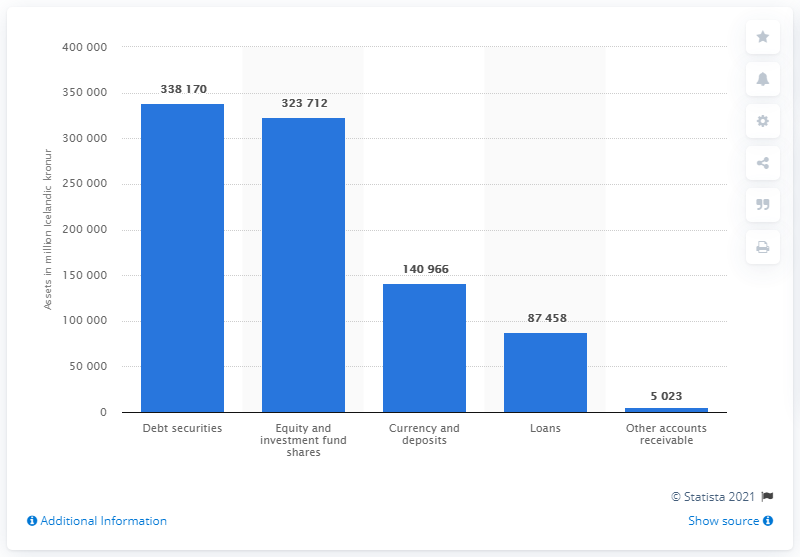Give some essential details in this illustration. In 2019, a total of 338,170 Icelandic kronur were invested in debt securities. In 2019, a total of 323,712 Icelandic krónur were invested in equity and investment fund shares. 